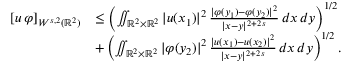Convert formula to latex. <formula><loc_0><loc_0><loc_500><loc_500>\begin{array} { r l } { [ u \, \varphi ] _ { W ^ { s , 2 } ( \mathbb { R } ^ { 2 } ) } } & { \leq \left ( \iint _ { \mathbb { R } ^ { 2 } \times \mathbb { R } ^ { 2 } } | u ( x _ { 1 } ) | ^ { 2 } \, \frac { | \varphi ( y _ { 1 } ) - \varphi ( y _ { 2 } ) | ^ { 2 } } { | x - y | ^ { 2 + 2 \, s } } \, d x \, d y \right ) ^ { 1 / 2 } } \\ & { + \left ( \iint _ { \mathbb { R } ^ { 2 } \times \mathbb { R } ^ { 2 } } | \varphi ( y _ { 2 } ) | ^ { 2 } \, \frac { | u ( x _ { 1 } ) - u ( x _ { 2 } ) | ^ { 2 } } { | x - y | ^ { 2 + 2 \, s } } \, d x \, d y \right ) ^ { 1 / 2 } . } \end{array}</formula> 